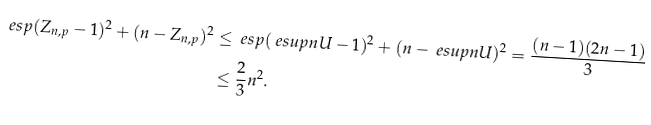Convert formula to latex. <formula><loc_0><loc_0><loc_500><loc_500>\ e s p { ( Z _ { n , p } - 1 ) ^ { 2 } + ( n - Z _ { n , p } ) ^ { 2 } } & \leq \ e s p { ( \ e s u p { n U } - 1 ) ^ { 2 } + ( n - \ e s u p { n U } ) ^ { 2 } } = \frac { ( n - 1 ) ( 2 n - 1 ) } { 3 } \\ & \leq \frac { 2 } { 3 } n ^ { 2 } .</formula> 